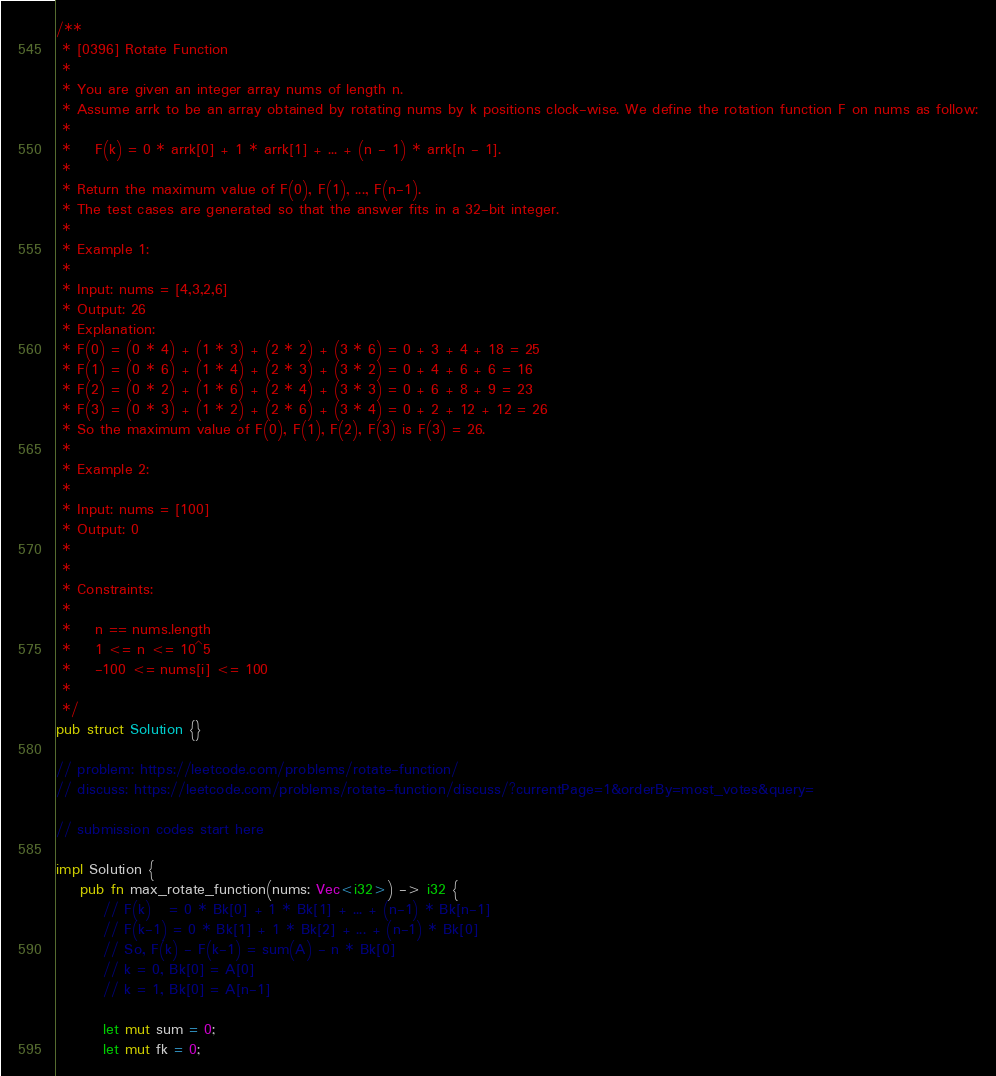Convert code to text. <code><loc_0><loc_0><loc_500><loc_500><_Rust_>/**
 * [0396] Rotate Function
 *
 * You are given an integer array nums of length n.
 * Assume arrk to be an array obtained by rotating nums by k positions clock-wise. We define the rotation function F on nums as follow:
 *
 * 	F(k) = 0 * arrk[0] + 1 * arrk[1] + ... + (n - 1) * arrk[n - 1].
 *
 * Return the maximum value of F(0), F(1), ..., F(n-1).
 * The test cases are generated so that the answer fits in a 32-bit integer.
 *  
 * Example 1:
 *
 * Input: nums = [4,3,2,6]
 * Output: 26
 * Explanation:
 * F(0) = (0 * 4) + (1 * 3) + (2 * 2) + (3 * 6) = 0 + 3 + 4 + 18 = 25
 * F(1) = (0 * 6) + (1 * 4) + (2 * 3) + (3 * 2) = 0 + 4 + 6 + 6 = 16
 * F(2) = (0 * 2) + (1 * 6) + (2 * 4) + (3 * 3) = 0 + 6 + 8 + 9 = 23
 * F(3) = (0 * 3) + (1 * 2) + (2 * 6) + (3 * 4) = 0 + 2 + 12 + 12 = 26
 * So the maximum value of F(0), F(1), F(2), F(3) is F(3) = 26.
 *
 * Example 2:
 *
 * Input: nums = [100]
 * Output: 0
 *
 *  
 * Constraints:
 *
 * 	n == nums.length
 * 	1 <= n <= 10^5
 * 	-100 <= nums[i] <= 100
 *
 */
pub struct Solution {}

// problem: https://leetcode.com/problems/rotate-function/
// discuss: https://leetcode.com/problems/rotate-function/discuss/?currentPage=1&orderBy=most_votes&query=

// submission codes start here

impl Solution {
    pub fn max_rotate_function(nums: Vec<i32>) -> i32 {
        // F(k)   = 0 * Bk[0] + 1 * Bk[1] + ... + (n-1) * Bk[n-1]
        // F(k-1) = 0 * Bk[1] + 1 * Bk[2] + ... + (n-1) * Bk[0]
        // So, F(k) - F(k-1) = sum(A) - n * Bk[0]
        // k = 0, Bk[0] = A[0]
        // k = 1, Bk[0] = A[n-1]

        let mut sum = 0;
        let mut fk = 0;</code> 